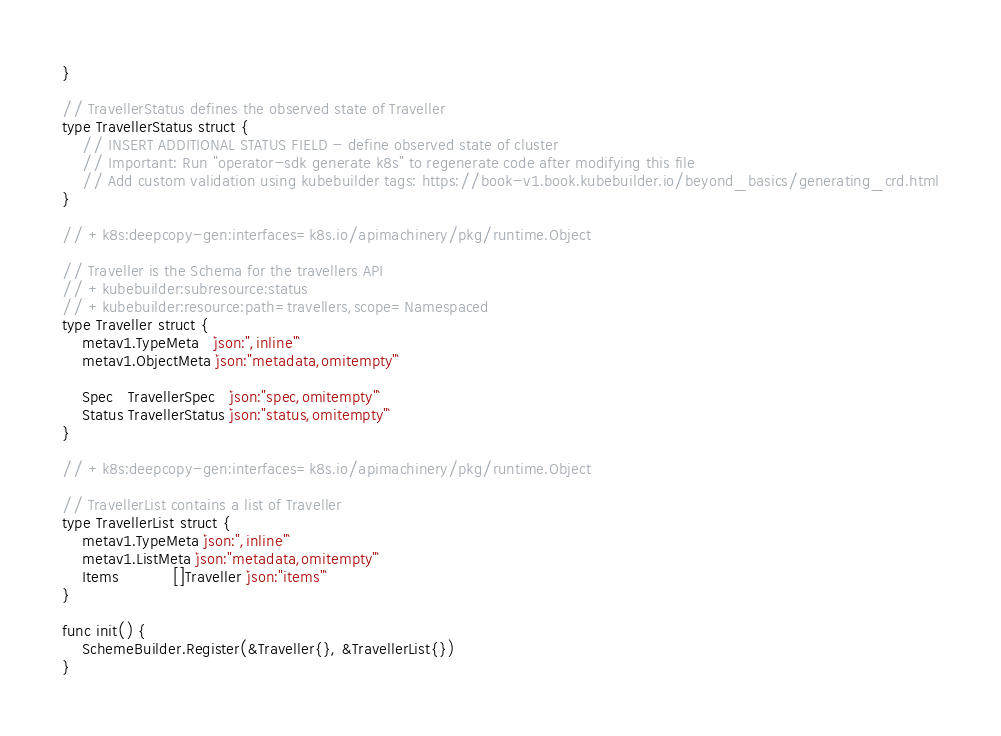Convert code to text. <code><loc_0><loc_0><loc_500><loc_500><_Go_>}

// TravellerStatus defines the observed state of Traveller
type TravellerStatus struct {
	// INSERT ADDITIONAL STATUS FIELD - define observed state of cluster
	// Important: Run "operator-sdk generate k8s" to regenerate code after modifying this file
	// Add custom validation using kubebuilder tags: https://book-v1.book.kubebuilder.io/beyond_basics/generating_crd.html
}

// +k8s:deepcopy-gen:interfaces=k8s.io/apimachinery/pkg/runtime.Object

// Traveller is the Schema for the travellers API
// +kubebuilder:subresource:status
// +kubebuilder:resource:path=travellers,scope=Namespaced
type Traveller struct {
	metav1.TypeMeta   `json:",inline"`
	metav1.ObjectMeta `json:"metadata,omitempty"`

	Spec   TravellerSpec   `json:"spec,omitempty"`
	Status TravellerStatus `json:"status,omitempty"`
}

// +k8s:deepcopy-gen:interfaces=k8s.io/apimachinery/pkg/runtime.Object

// TravellerList contains a list of Traveller
type TravellerList struct {
	metav1.TypeMeta `json:",inline"`
	metav1.ListMeta `json:"metadata,omitempty"`
	Items           []Traveller `json:"items"`
}

func init() {
	SchemeBuilder.Register(&Traveller{}, &TravellerList{})
}
</code> 